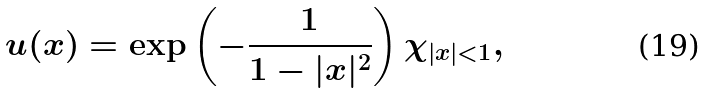Convert formula to latex. <formula><loc_0><loc_0><loc_500><loc_500>u ( x ) = \exp \left ( - \frac { 1 } { 1 - | x | ^ { 2 } } \right ) \chi _ { | x | < 1 } ,</formula> 